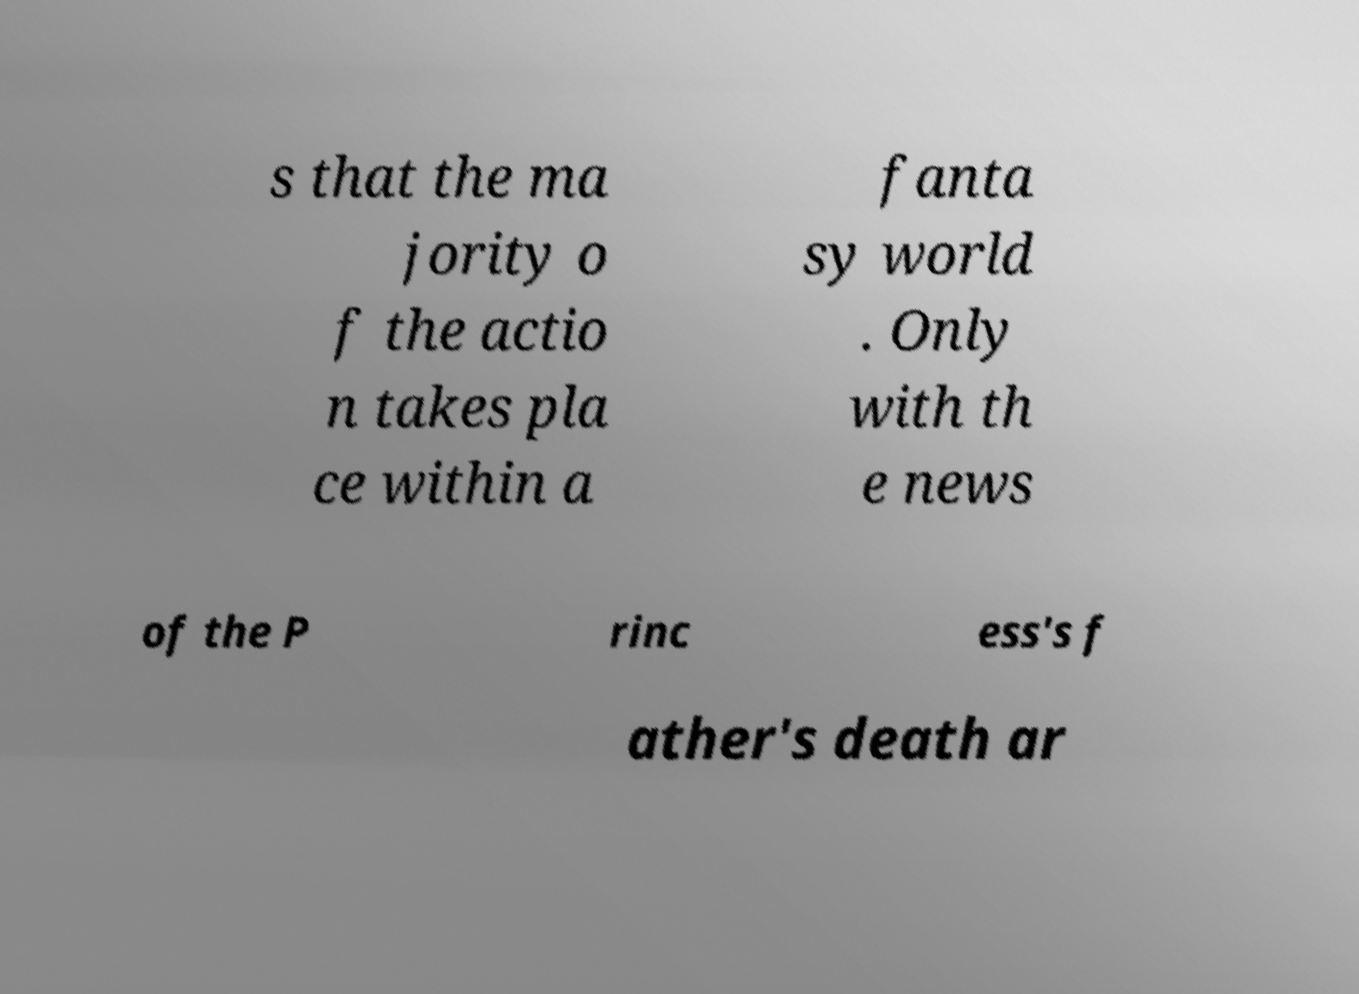Could you assist in decoding the text presented in this image and type it out clearly? s that the ma jority o f the actio n takes pla ce within a fanta sy world . Only with th e news of the P rinc ess's f ather's death ar 